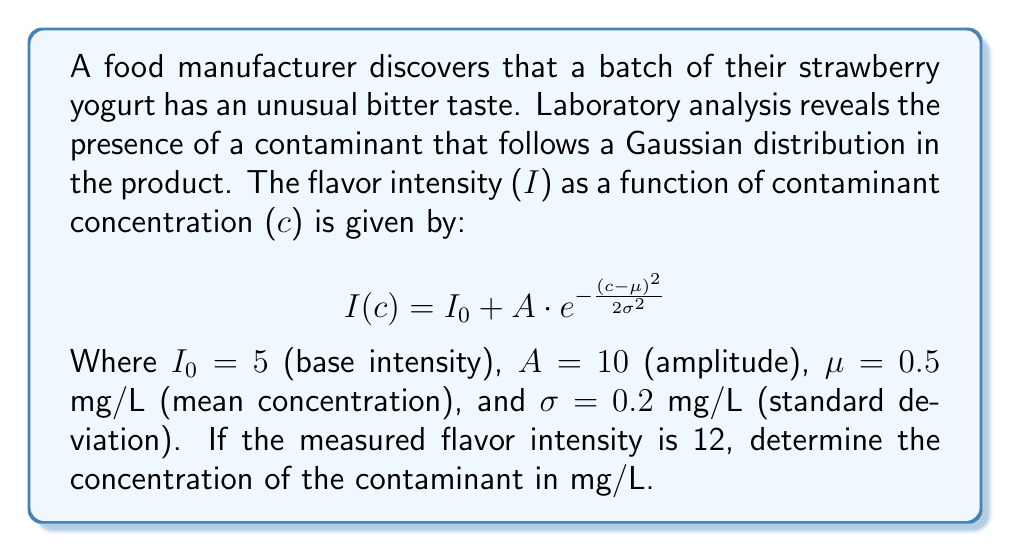Solve this math problem. To solve this inverse problem, we need to find the concentration (c) that corresponds to the given flavor intensity (I). Let's approach this step-by-step:

1) We're given the equation:
   $$I(c) = I_0 + A \cdot e^{-\frac{(c-\mu)^2}{2\sigma^2}}$$

2) We know the following values:
   $I_0 = 5$, $A = 10$, $\mu = 0.5$, $\sigma = 0.2$, and $I = 12$

3) Let's substitute these values into the equation:
   $$12 = 5 + 10 \cdot e^{-\frac{(c-0.5)^2}{2(0.2)^2}}$$

4) Simplify:
   $$7 = 10 \cdot e^{-\frac{(c-0.5)^2}{0.08}}$$

5) Divide both sides by 10:
   $$0.7 = e^{-\frac{(c-0.5)^2}{0.08}}$$

6) Take the natural log of both sides:
   $$\ln(0.7) = -\frac{(c-0.5)^2}{0.08}$$

7) Multiply both sides by -0.08:
   $$-0.08 \ln(0.7) = (c-0.5)^2$$

8) Take the square root of both sides:
   $$\sqrt{-0.08 \ln(0.7)} = |c-0.5|$$

9) Solve for c:
   $$c = 0.5 \pm \sqrt{-0.08 \ln(0.7)}$$

10) Calculate:
    $$c \approx 0.5 \pm 0.2828$$

11) This gives us two possible solutions: $c \approx 0.7828$ or $c \approx 0.2172$

12) Given that $\mu = 0.5$, the concentration $c \approx 0.7828$ mg/L is more likely as it's closer to the mean.
Answer: 0.7828 mg/L 